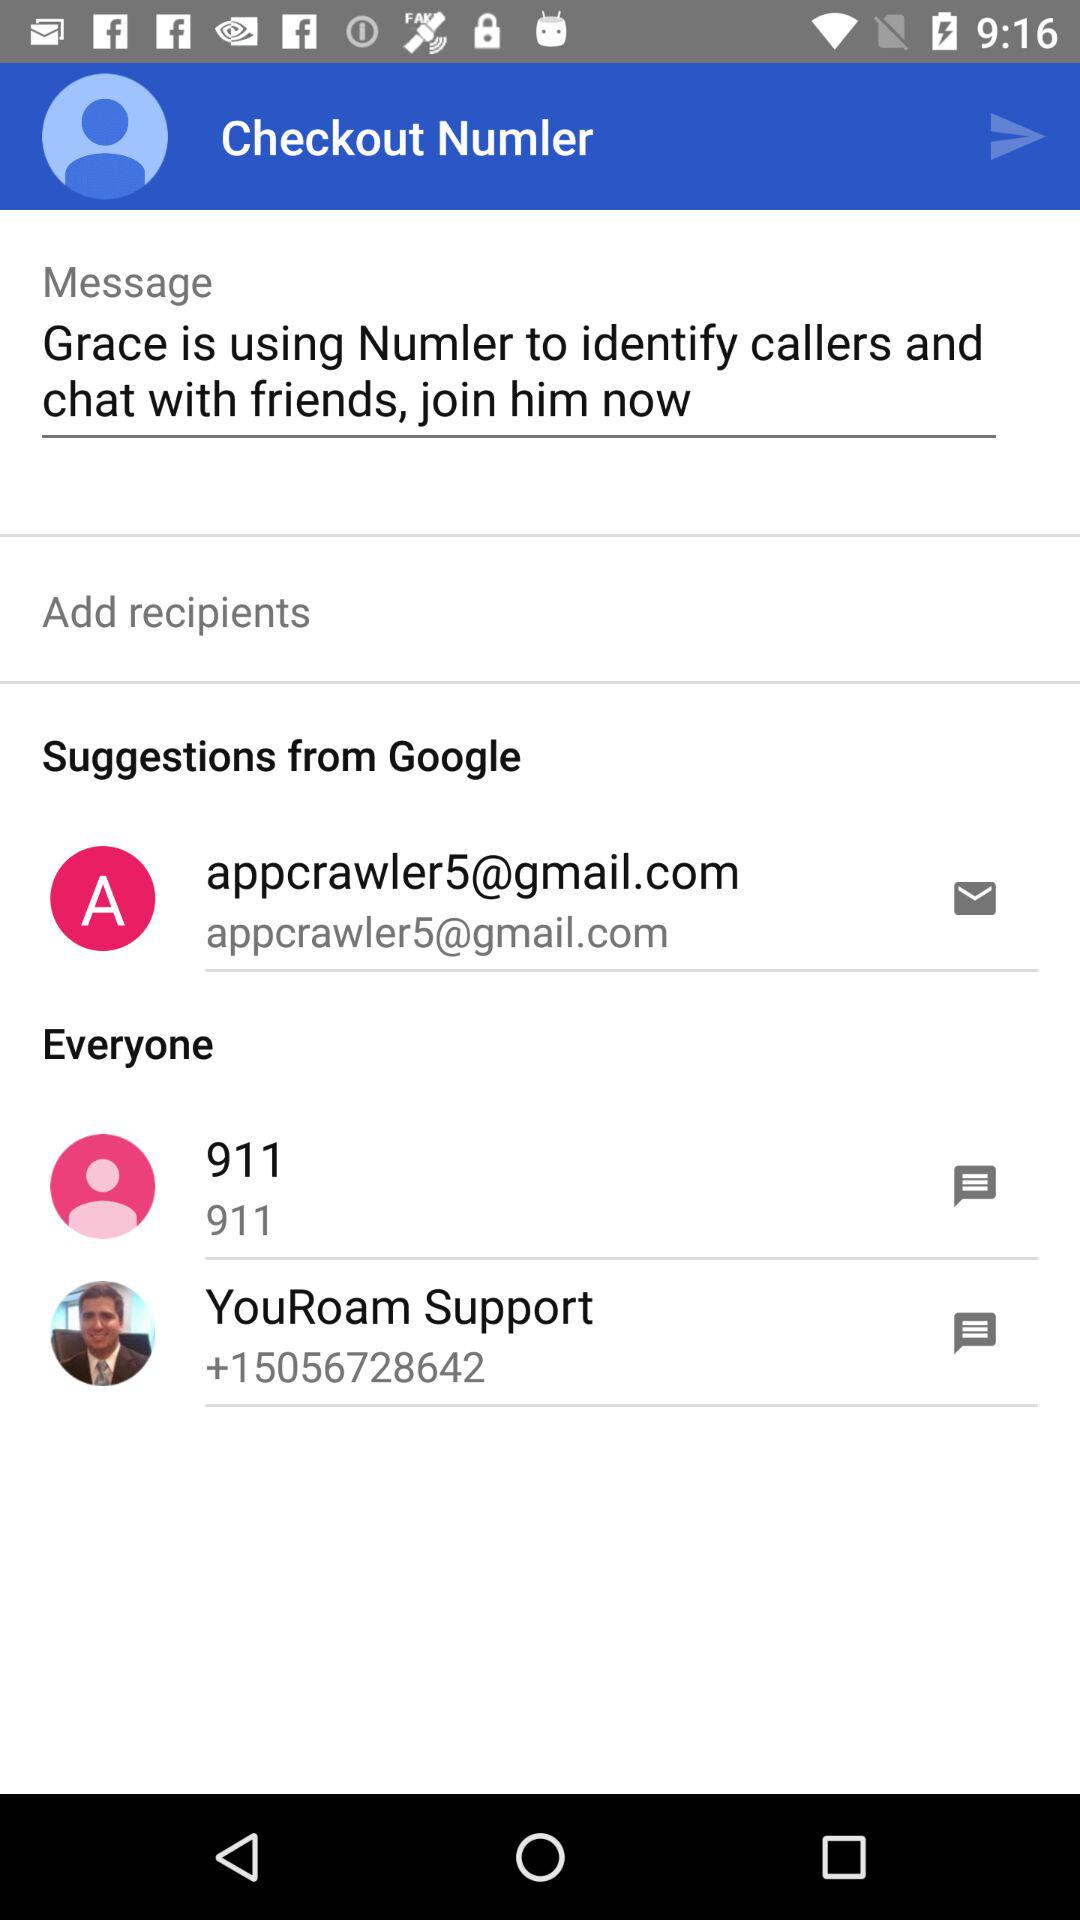What is the YouRoam Support number? The YouRoam Support number is "+15056728642". 